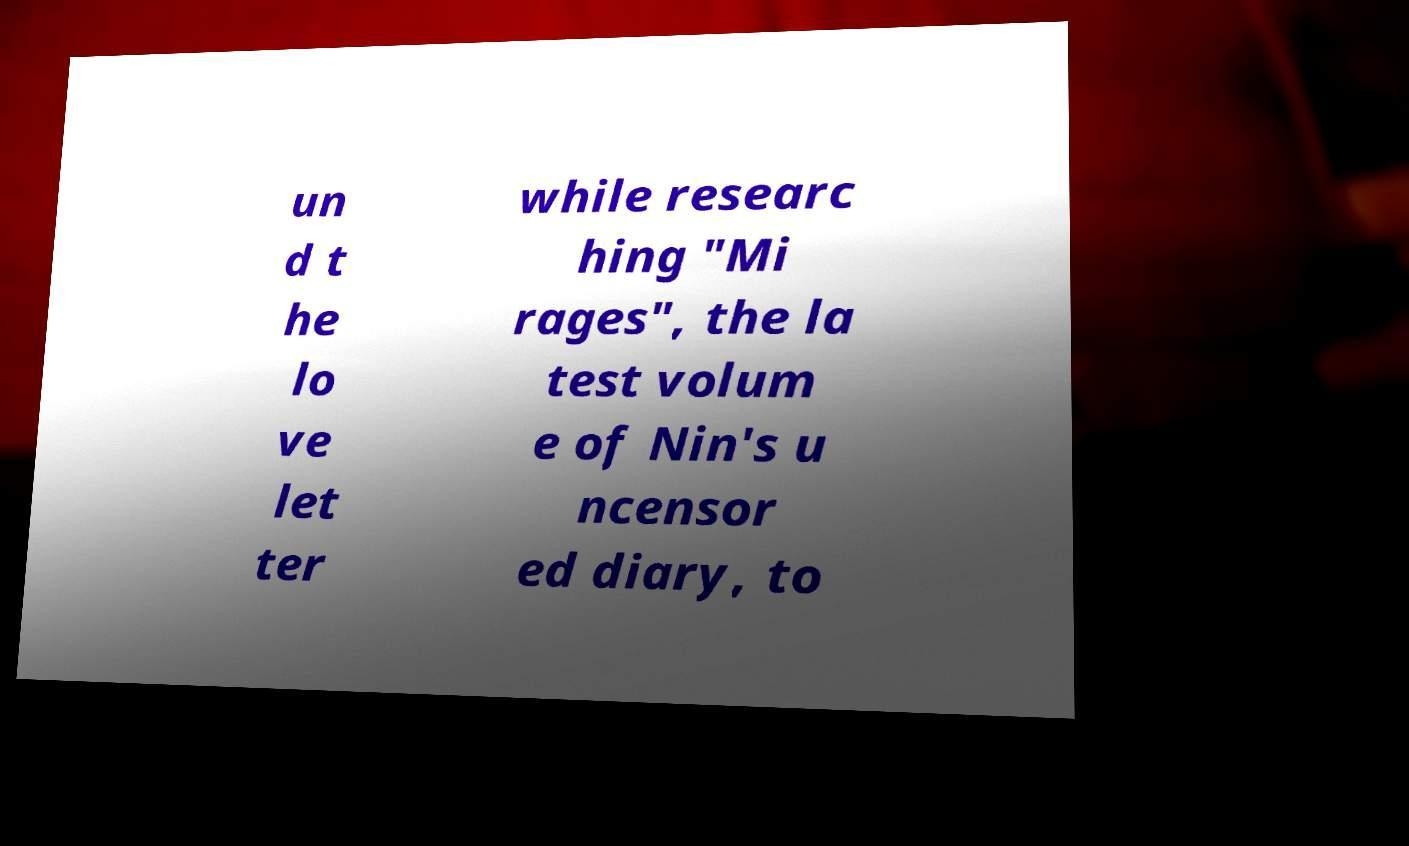I need the written content from this picture converted into text. Can you do that? un d t he lo ve let ter while researc hing "Mi rages", the la test volum e of Nin's u ncensor ed diary, to 